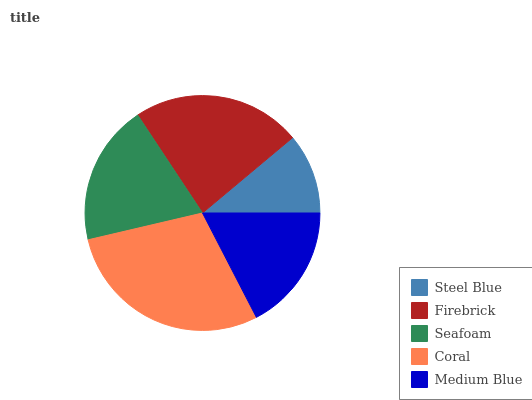Is Steel Blue the minimum?
Answer yes or no. Yes. Is Coral the maximum?
Answer yes or no. Yes. Is Firebrick the minimum?
Answer yes or no. No. Is Firebrick the maximum?
Answer yes or no. No. Is Firebrick greater than Steel Blue?
Answer yes or no. Yes. Is Steel Blue less than Firebrick?
Answer yes or no. Yes. Is Steel Blue greater than Firebrick?
Answer yes or no. No. Is Firebrick less than Steel Blue?
Answer yes or no. No. Is Seafoam the high median?
Answer yes or no. Yes. Is Seafoam the low median?
Answer yes or no. Yes. Is Coral the high median?
Answer yes or no. No. Is Steel Blue the low median?
Answer yes or no. No. 